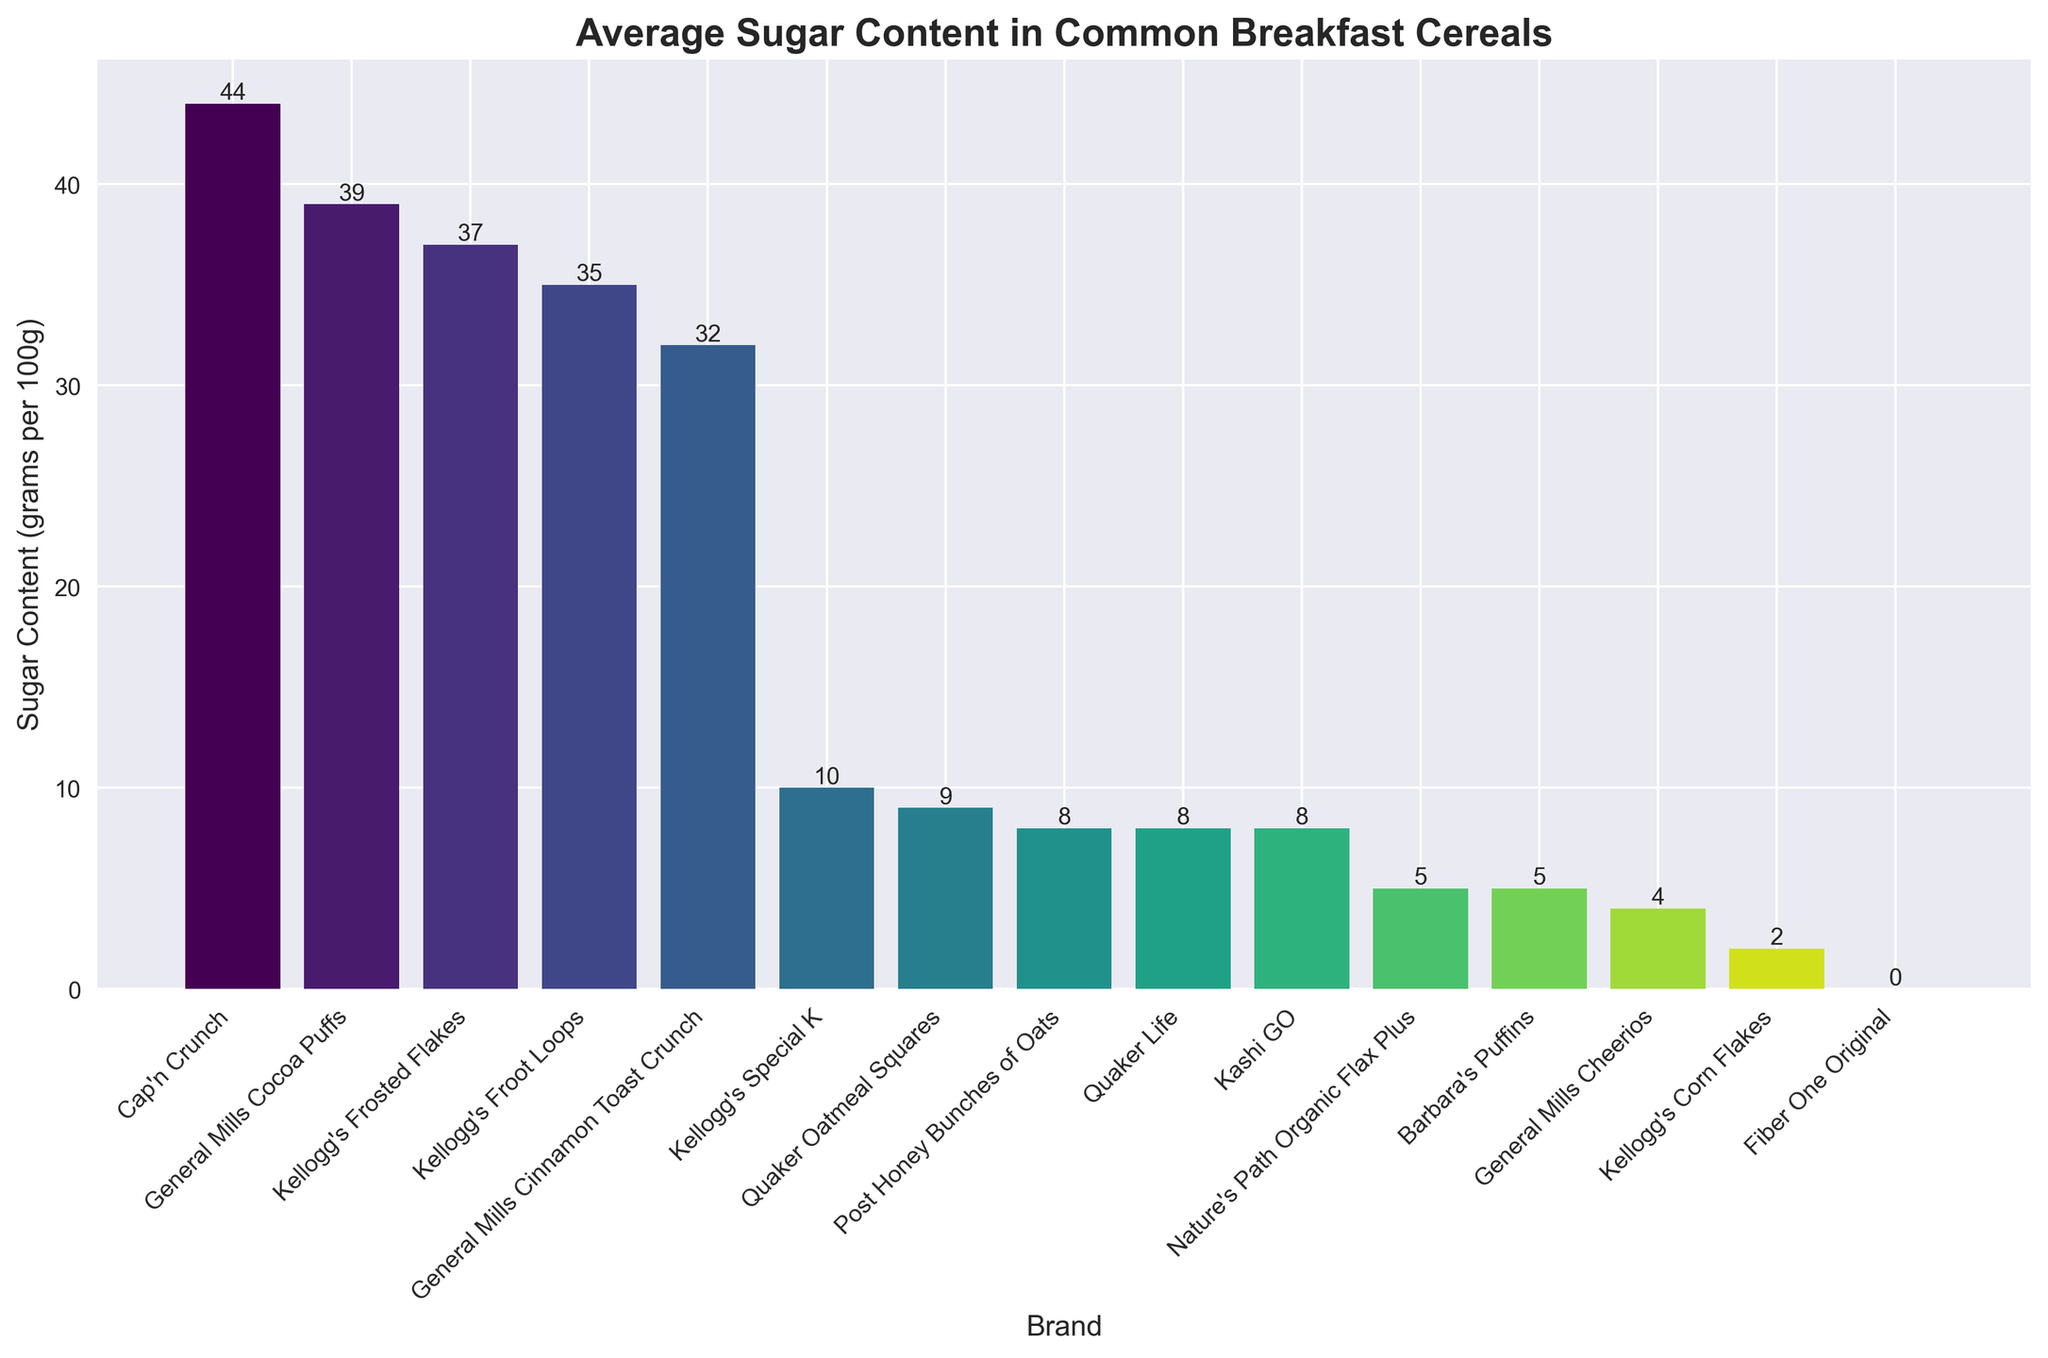Which cereal brand has the highest sugar content? The brand with the highest bar represents the cereal with the highest sugar content. In this case, Cap'n Crunch has the highest bar.
Answer: Cap'n Crunch Which cereal brand has the lowest sugar content? The brand with the lowest bar represents the cereal with the lowest sugar content. In this case, Fiber One Original has the lowest bar.
Answer: Fiber One Original Compare the sugar content of Kellogg's Frosted Flakes and General Mills Cheerios. Which one contains more sugar? Kellogg's Frosted Flakes has a taller bar than General Mills Cheerios, indicating that Frosted Flakes has a higher sugar content.
Answer: Kellogg's Frosted Flakes What is the difference in sugar content between Cap'n Crunch and Kellogg's Corn Flakes? Cap'n Crunch has a sugar content of 44 grams per 100g, and Kellogg's Corn Flakes has 2 grams per 100g. The difference is 44 - 2 = 42 grams.
Answer: 42 grams What's the average sugar content of all cereals listed? Adding all sugar contents and dividing by the number of brands: (37 + 4 + 8 + 8 + 8 + 5 + 44 + 10 + 32 + 0 + 35 + 9 + 5 + 2 + 39) / 15 = 18.2 grams.
Answer: 18.2 grams How many cereals have a sugar content of 10 grams or less? Brands with 10 grams or fewer listed are General Mills Cheerios, Nature's Path Organic Flax Plus, Fiber One Original, Barbara's Puffins, Kellogg's Corn Flakes, and Quaker Oatmeal Squares. Count them: 6 brands.
Answer: 6 brands What is the total sugar content of all Kellogg's cereals listed? Kellogg's cereals are Frosted Flakes (37 grams), Special K (10 grams), Froot Loops (35 grams), and Corn Flakes (2 grams). Summing these gives 37 + 10 + 35 + 2 = 84 grams.
Answer: 84 grams Which brand has more sugar: Quaker Oatmeal Squares or Barbara's Puffins? The bars of Quaker Oatmeal Squares and Barbara's Puffins show that Quaker Oatmeal Squares (9 grams) has slightly more sugar than Barbara's Puffins (5 grams).
Answer: Quaker Oatmeal Squares Identify the cereals that have a higher sugar content than Kellogg's Special K. Kellogg's Special K has 10 grams of sugar content. Cereals with higher content are Kellogg's Frosted Flakes (37 grams), Cap'n Crunch (44 grams), General Mills Cinnamon Toast Crunch (32 grams), Kellogg's Froot Loops (35 grams), and General Mills Cocoa Puffs (39 grams).
Answer: Kellogg's Frosted Flakes, Cap'n Crunch, General Mills Cinnamon Toast Crunch, Kellogg's Froot Loops, General Mills Cocoa Puffs What is the median sugar content of the cereals listed? Sorting the sugar contents in ascending order: 0, 2, 4, 5, 5, 8, 8, 8, 9, 10, 32, 35, 37, 39, 44. The median value is the 8th value in this list: 8 grams.
Answer: 8 grams 